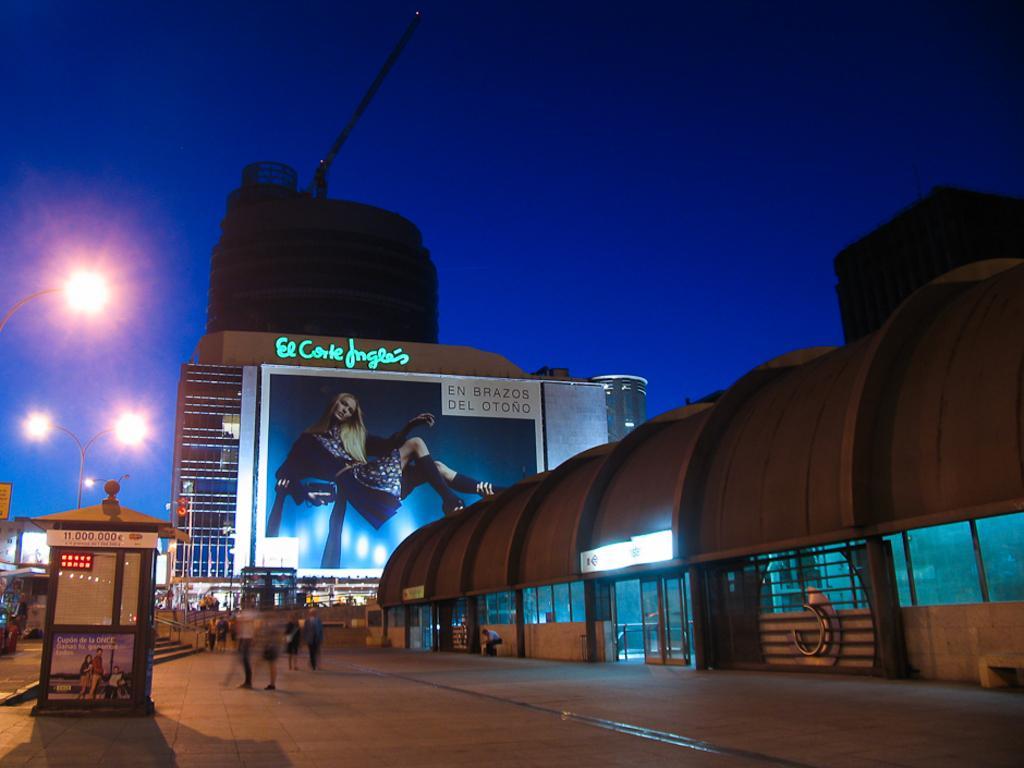Could you give a brief overview of what you see in this image? At the bottom of the image there is a floor. On the floor there are few people standing. And on the right side there is a building with walls, glass windows and doors. In the background there are buildings with posters and also there are poles with lamps. 